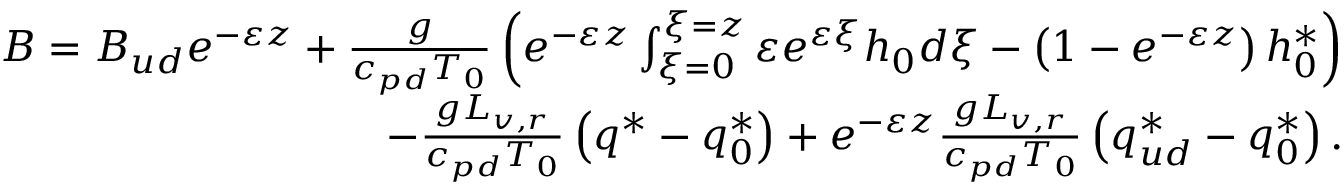<formula> <loc_0><loc_0><loc_500><loc_500>\begin{array} { r } { B = B _ { u d } e ^ { - \varepsilon z } + \frac { g } { c _ { p d } T _ { 0 } } \left ( e ^ { - \varepsilon z } \int _ { \xi = 0 } ^ { \xi = z } \varepsilon e ^ { \varepsilon \xi } h _ { 0 } d \xi - \left ( 1 - e ^ { - \varepsilon z } \right ) h _ { 0 } ^ { * } \right ) } \\ { - \frac { g L _ { v , r } } { c _ { p d } T _ { 0 } } \left ( q ^ { * } - q _ { 0 } ^ { * } \right ) + e ^ { - \varepsilon z } \frac { g L _ { v , r } } { c _ { p d } T _ { 0 } } \left ( q _ { u d } ^ { * } - q _ { 0 } ^ { * } \right ) . } \end{array}</formula> 